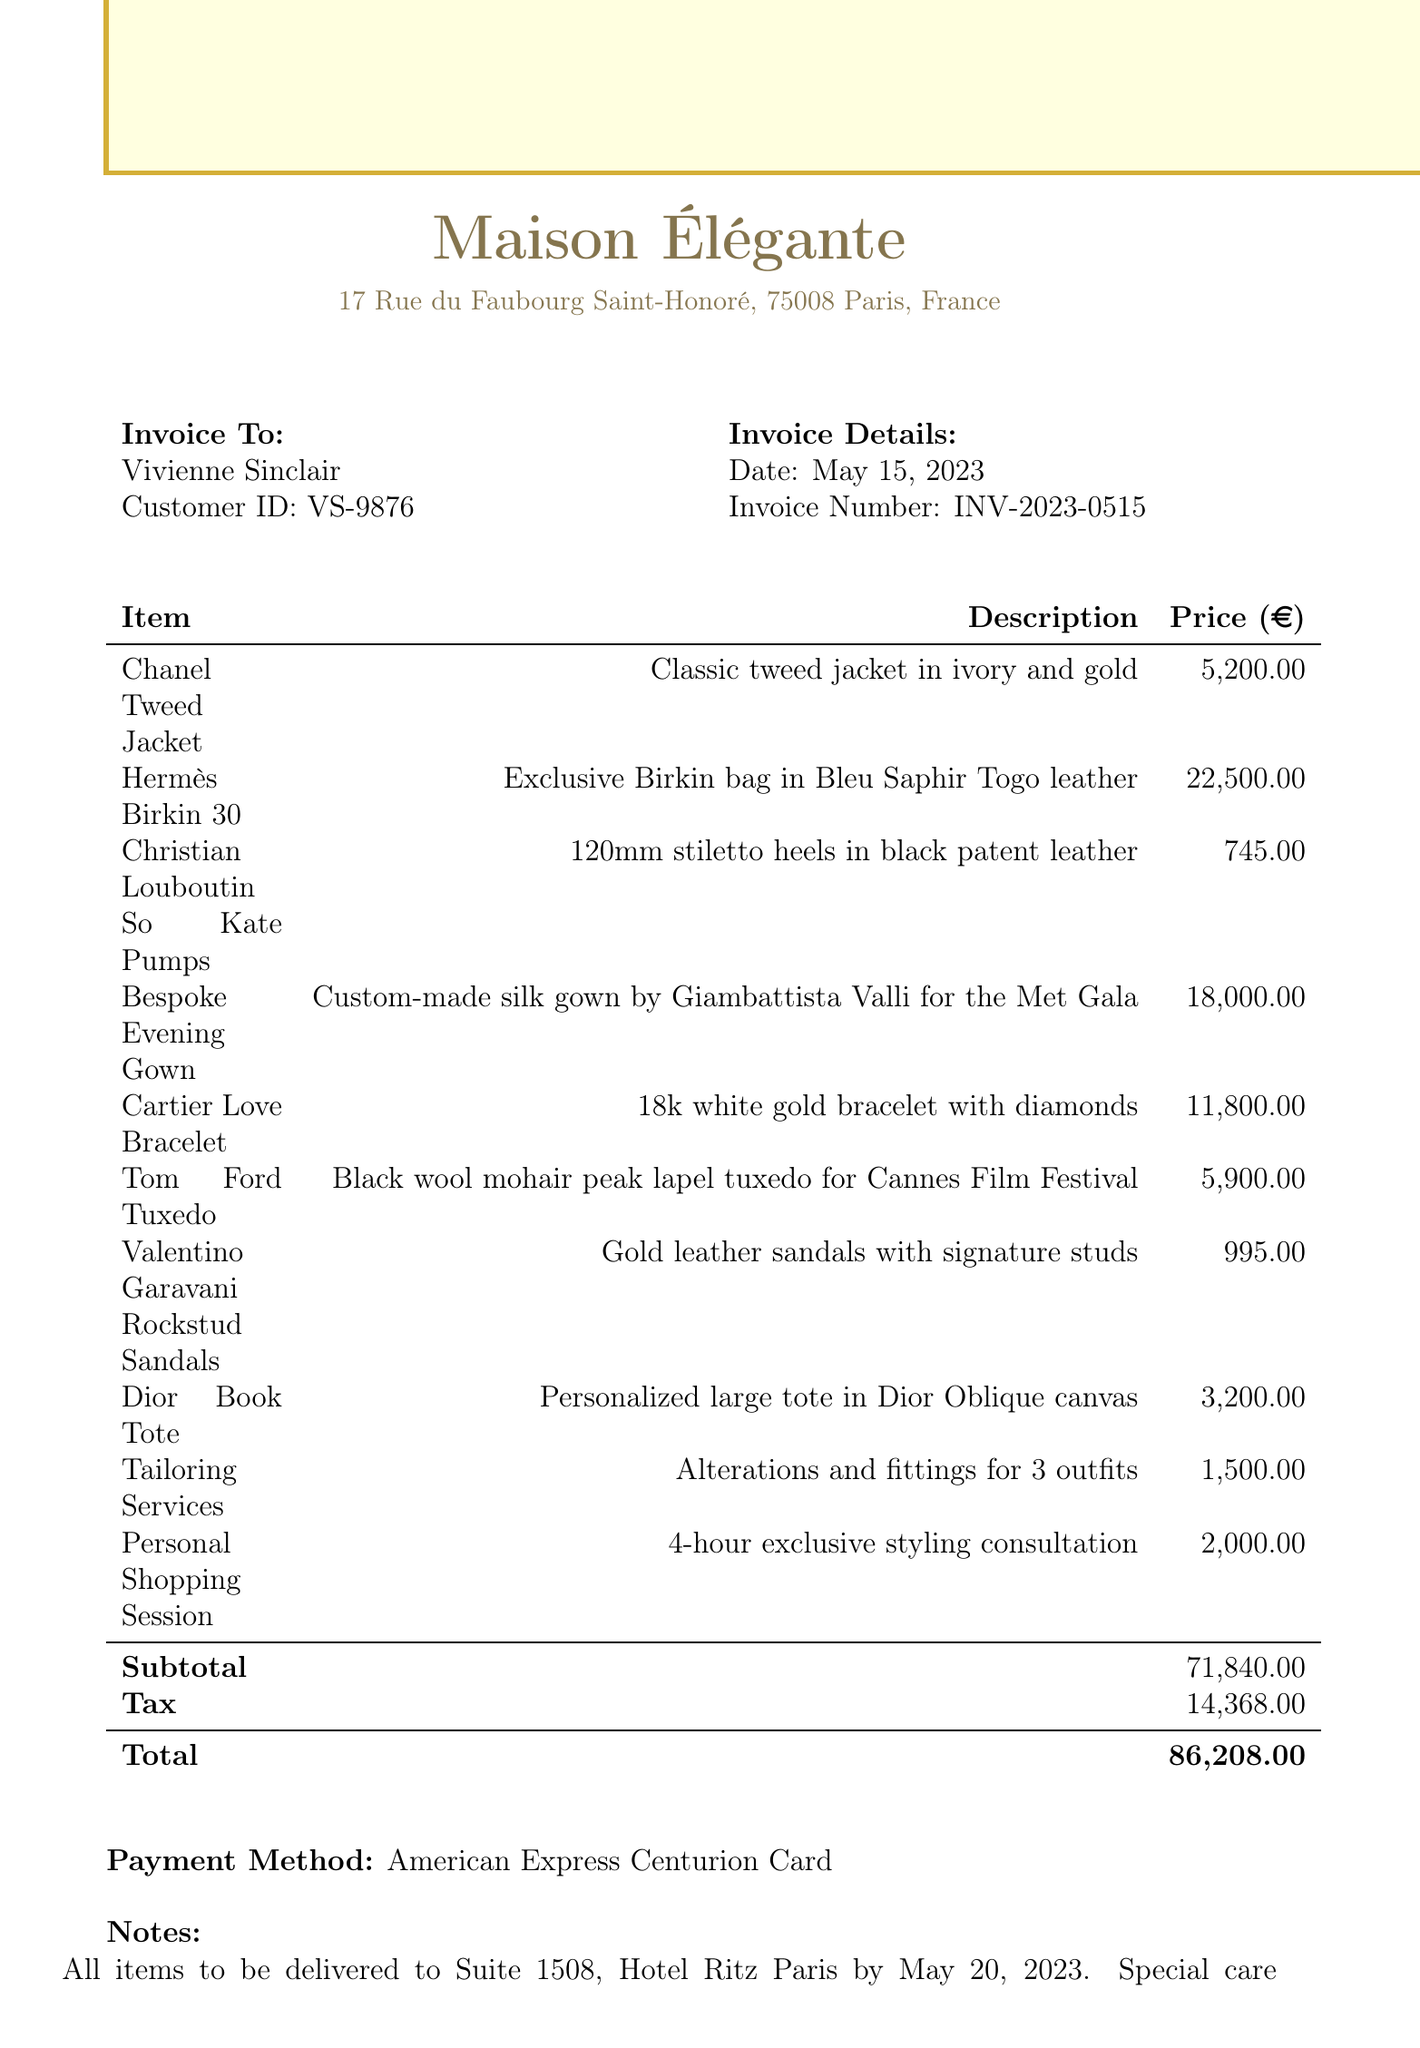What is the boutique name? The boutique name is listed at the top of the invoice.
Answer: Maison Élégante What is the date of the invoice? The date is found in the invoice details section.
Answer: May 15, 2023 Who is the customer? The customer's name is located in the invoice to section.
Answer: Vivienne Sinclair What is the total amount due? The total amount is summarized at the end of the itemized list.
Answer: 86,208.00 How many items are listed? The number of items can be counted in the itemized section of the invoice.
Answer: 10 What is the price of the Hermès Birkin 30? The price of the item is mentioned in the itemized list.
Answer: 22,500.00 What services are included in the invoice? The services are listed under the items, particularly in tailoring and personal shopping.
Answer: Tailoring Services, Personal Shopping Session When is the delivery date? The delivery date is specified in the notes section at the bottom of the invoice.
Answer: May 20, 2023 What payment method was used? The payment method is noted right before the notes section.
Answer: American Express Centurion Card 